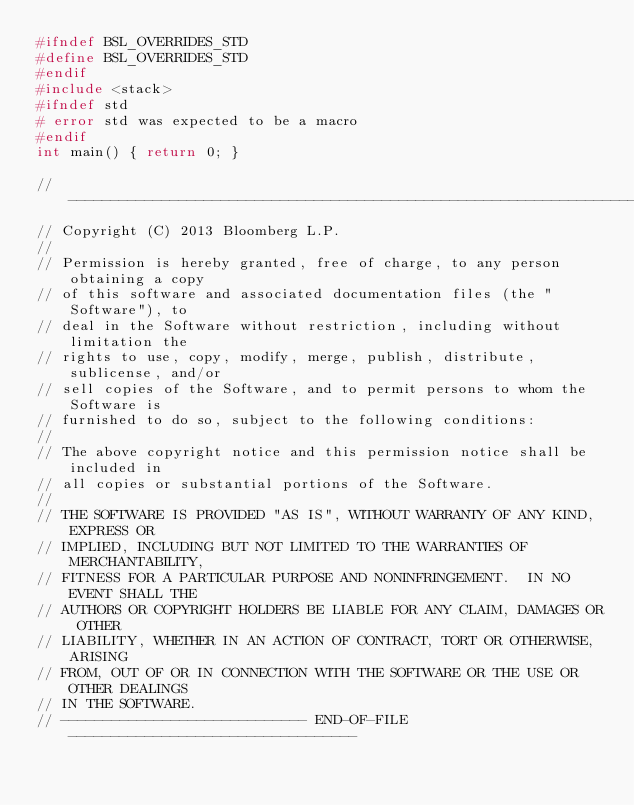<code> <loc_0><loc_0><loc_500><loc_500><_C++_>#ifndef BSL_OVERRIDES_STD
#define BSL_OVERRIDES_STD
#endif
#include <stack>
#ifndef std
# error std was expected to be a macro
#endif
int main() { return 0; }

// ----------------------------------------------------------------------------
// Copyright (C) 2013 Bloomberg L.P.
//
// Permission is hereby granted, free of charge, to any person obtaining a copy
// of this software and associated documentation files (the "Software"), to
// deal in the Software without restriction, including without limitation the
// rights to use, copy, modify, merge, publish, distribute, sublicense, and/or
// sell copies of the Software, and to permit persons to whom the Software is
// furnished to do so, subject to the following conditions:
//
// The above copyright notice and this permission notice shall be included in
// all copies or substantial portions of the Software.
//
// THE SOFTWARE IS PROVIDED "AS IS", WITHOUT WARRANTY OF ANY KIND, EXPRESS OR
// IMPLIED, INCLUDING BUT NOT LIMITED TO THE WARRANTIES OF MERCHANTABILITY,
// FITNESS FOR A PARTICULAR PURPOSE AND NONINFRINGEMENT.  IN NO EVENT SHALL THE
// AUTHORS OR COPYRIGHT HOLDERS BE LIABLE FOR ANY CLAIM, DAMAGES OR OTHER
// LIABILITY, WHETHER IN AN ACTION OF CONTRACT, TORT OR OTHERWISE, ARISING
// FROM, OUT OF OR IN CONNECTION WITH THE SOFTWARE OR THE USE OR OTHER DEALINGS
// IN THE SOFTWARE.
// ----------------------------- END-OF-FILE ----------------------------------
</code> 